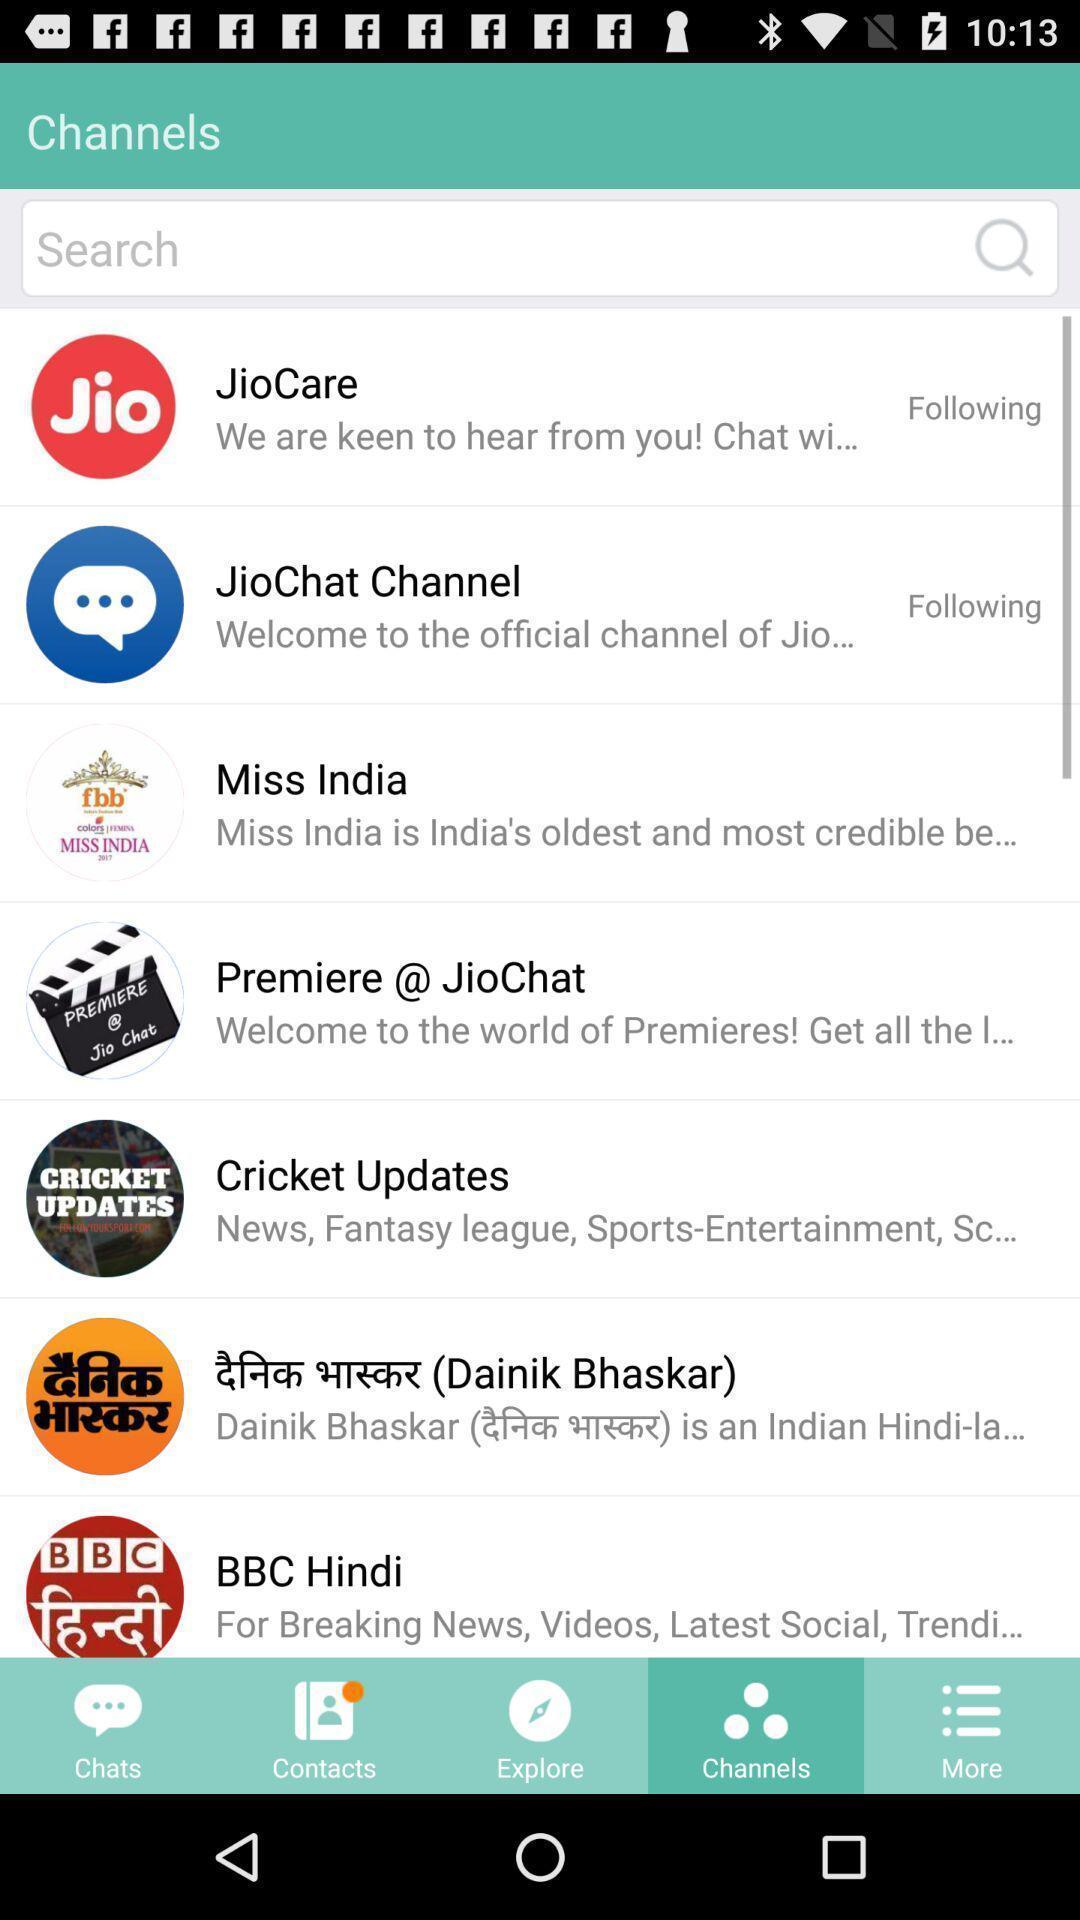Give me a narrative description of this picture. Search bar to search for channels in app. 